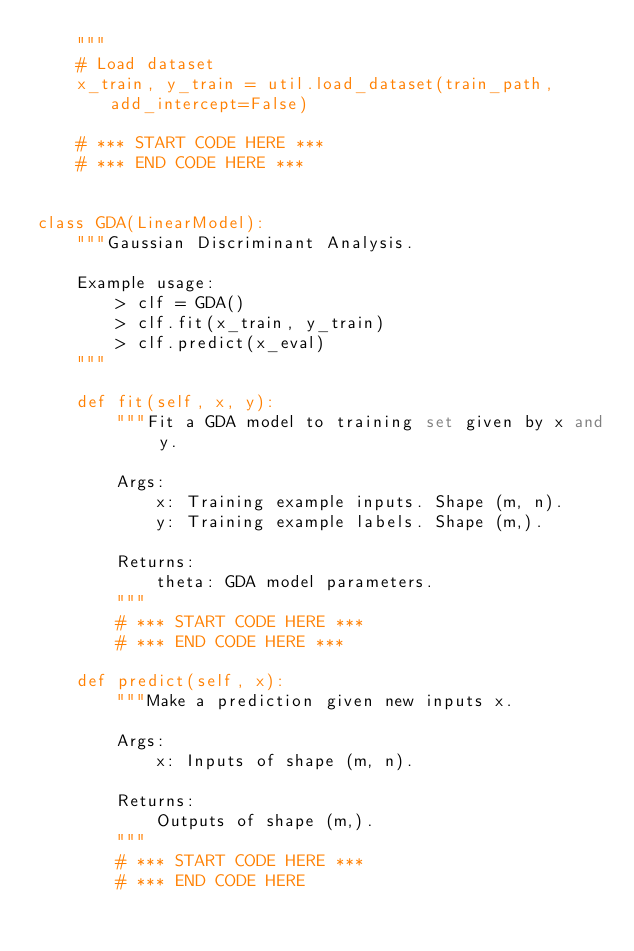<code> <loc_0><loc_0><loc_500><loc_500><_Python_>    """
    # Load dataset
    x_train, y_train = util.load_dataset(train_path, add_intercept=False)

    # *** START CODE HERE ***
    # *** END CODE HERE ***


class GDA(LinearModel):
    """Gaussian Discriminant Analysis.

    Example usage:
        > clf = GDA()
        > clf.fit(x_train, y_train)
        > clf.predict(x_eval)
    """

    def fit(self, x, y):
        """Fit a GDA model to training set given by x and y.

        Args:
            x: Training example inputs. Shape (m, n).
            y: Training example labels. Shape (m,).

        Returns:
            theta: GDA model parameters.
        """
        # *** START CODE HERE ***
        # *** END CODE HERE ***

    def predict(self, x):
        """Make a prediction given new inputs x.

        Args:
            x: Inputs of shape (m, n).

        Returns:
            Outputs of shape (m,).
        """
        # *** START CODE HERE ***
        # *** END CODE HERE
</code> 